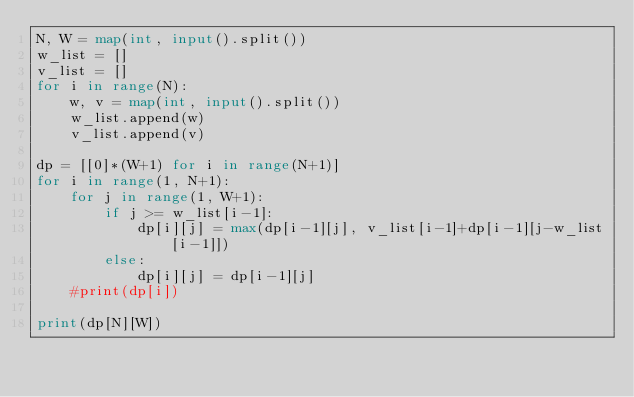Convert code to text. <code><loc_0><loc_0><loc_500><loc_500><_Python_>N, W = map(int, input().split())
w_list = []
v_list = []
for i in range(N):
    w, v = map(int, input().split())
    w_list.append(w)
    v_list.append(v)

dp = [[0]*(W+1) for i in range(N+1)]
for i in range(1, N+1):
    for j in range(1, W+1):
        if j >= w_list[i-1]:
            dp[i][j] = max(dp[i-1][j], v_list[i-1]+dp[i-1][j-w_list[i-1]])
        else:
            dp[i][j] = dp[i-1][j]
    #print(dp[i])    

print(dp[N][W])</code> 